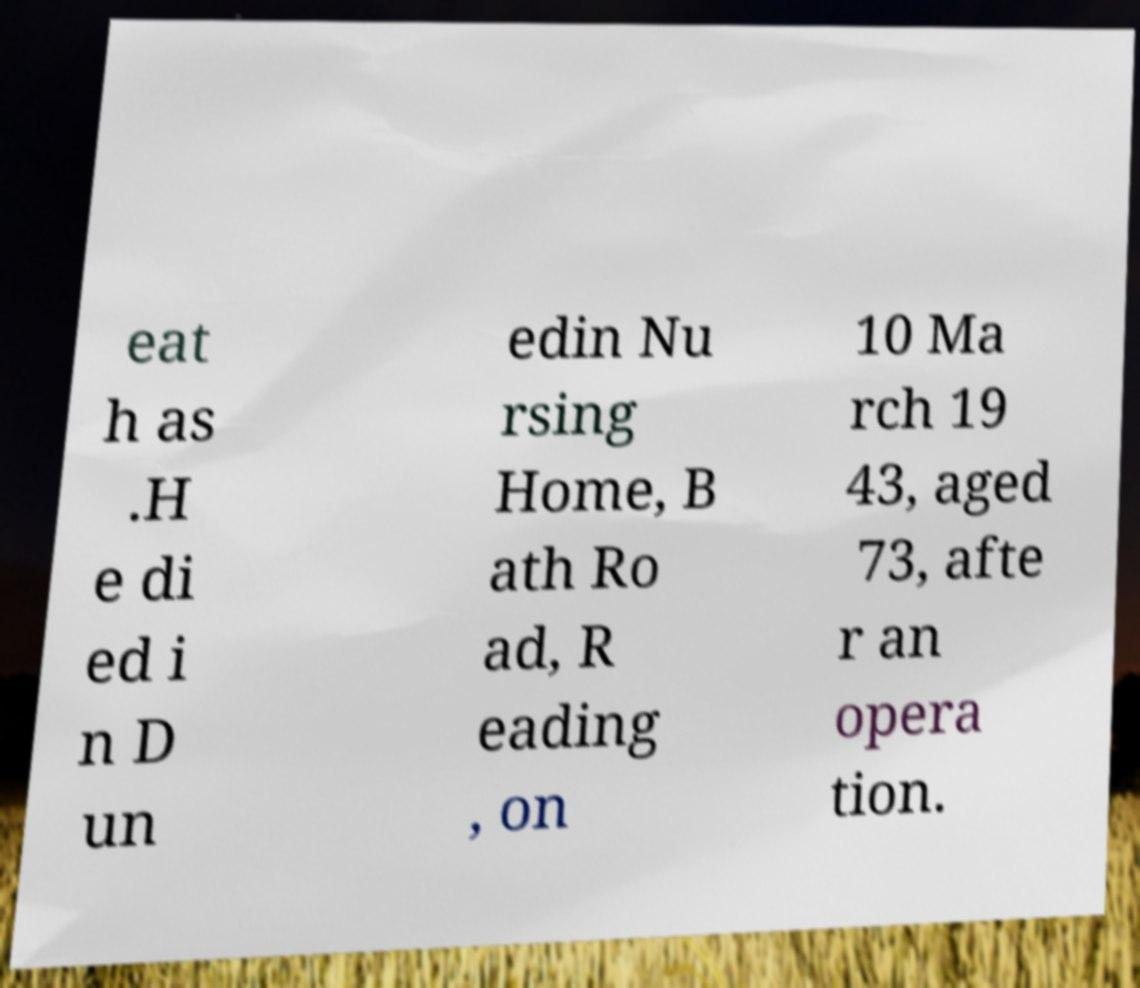For documentation purposes, I need the text within this image transcribed. Could you provide that? eat h as .H e di ed i n D un edin Nu rsing Home, B ath Ro ad, R eading , on 10 Ma rch 19 43, aged 73, afte r an opera tion. 